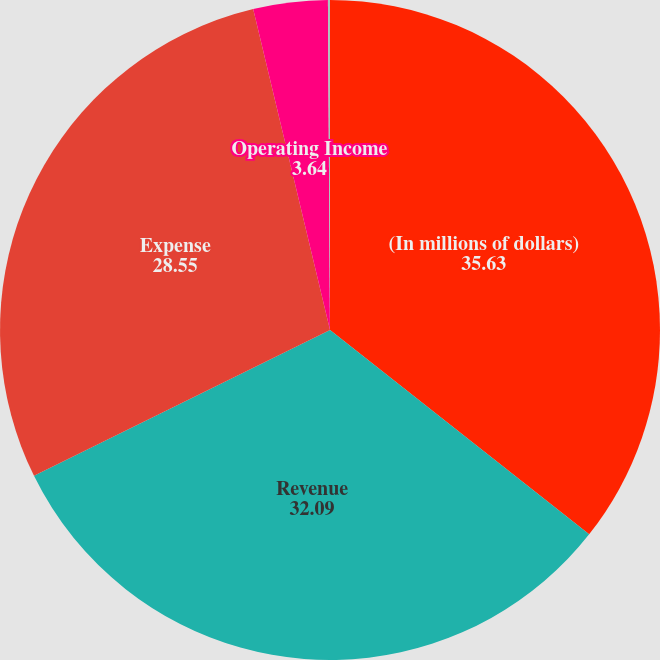<chart> <loc_0><loc_0><loc_500><loc_500><pie_chart><fcel>(In millions of dollars)<fcel>Revenue<fcel>Expense<fcel>Operating Income<fcel>Operating Income Margin<nl><fcel>35.63%<fcel>32.09%<fcel>28.55%<fcel>3.64%<fcel>0.1%<nl></chart> 